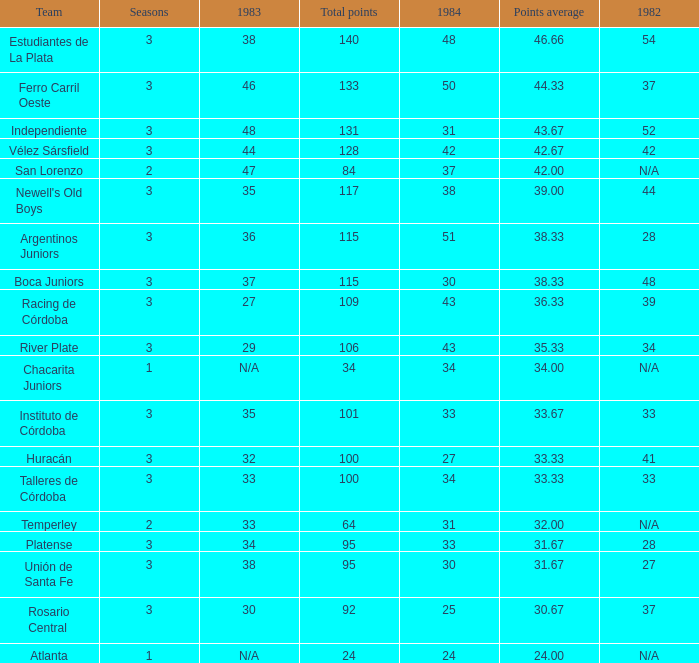What is the total for 1984 for the team with 100 points total and more than 3 seasons? None. 